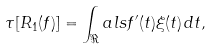Convert formula to latex. <formula><loc_0><loc_0><loc_500><loc_500>\tau [ R _ { 1 } ( f ) ] = \int _ { \Re } a l s f ^ { \prime } ( t ) \xi ( t ) \, d t ,</formula> 